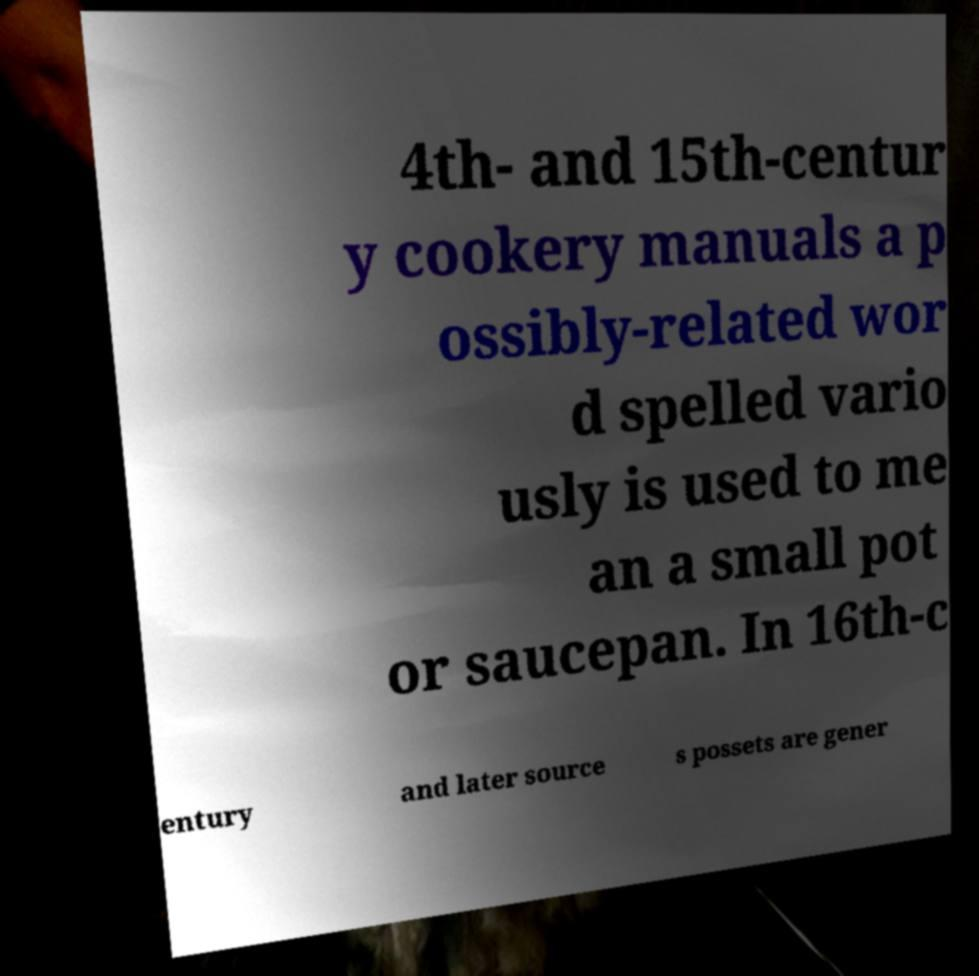What messages or text are displayed in this image? I need them in a readable, typed format. 4th- and 15th-centur y cookery manuals a p ossibly-related wor d spelled vario usly is used to me an a small pot or saucepan. In 16th-c entury and later source s possets are gener 